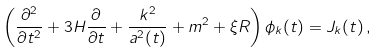Convert formula to latex. <formula><loc_0><loc_0><loc_500><loc_500>\left ( \frac { \partial ^ { 2 } } { \partial { t } ^ { 2 } } + 3 H \frac { \partial } { \partial t } + \frac { k ^ { 2 } } { a ^ { 2 } ( t ) } + m ^ { 2 } + \xi R \right ) \phi _ { k } ( t ) = J _ { k } ( t ) \, ,</formula> 